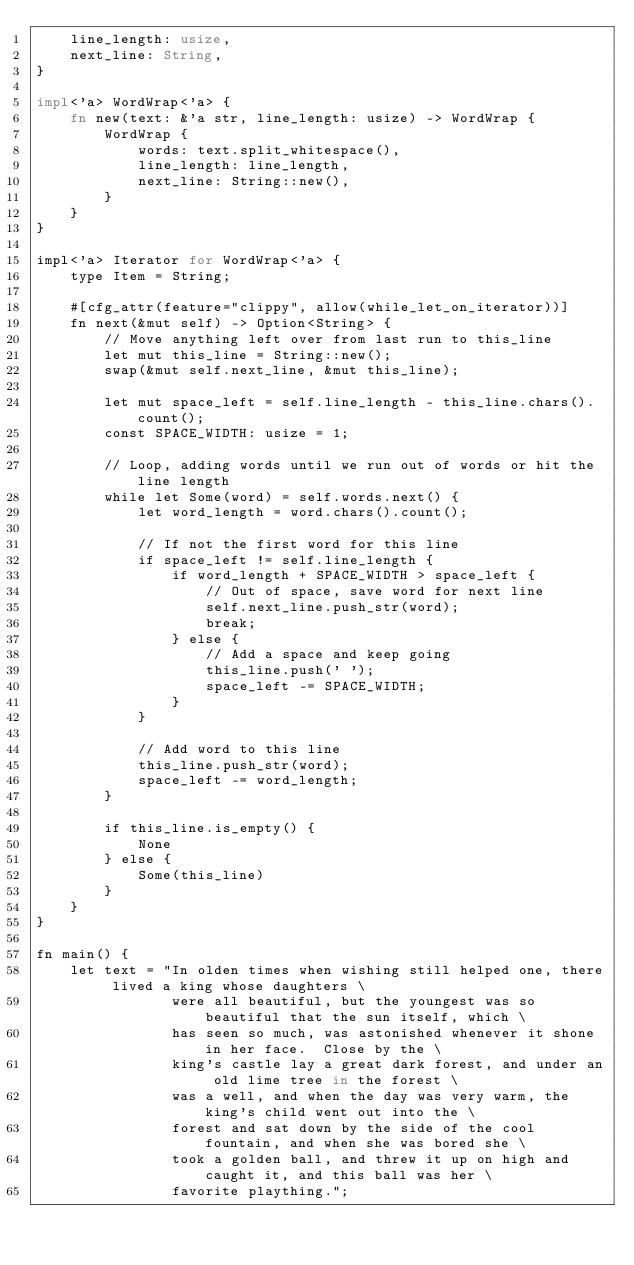<code> <loc_0><loc_0><loc_500><loc_500><_Rust_>    line_length: usize,
    next_line: String,
}

impl<'a> WordWrap<'a> {
    fn new(text: &'a str, line_length: usize) -> WordWrap {
        WordWrap {
            words: text.split_whitespace(),
            line_length: line_length,
            next_line: String::new(),
        }
    }
}

impl<'a> Iterator for WordWrap<'a> {
    type Item = String;

    #[cfg_attr(feature="clippy", allow(while_let_on_iterator))]
    fn next(&mut self) -> Option<String> {
        // Move anything left over from last run to this_line
        let mut this_line = String::new();
        swap(&mut self.next_line, &mut this_line);

        let mut space_left = self.line_length - this_line.chars().count();
        const SPACE_WIDTH: usize = 1;

        // Loop, adding words until we run out of words or hit the line length
        while let Some(word) = self.words.next() {
            let word_length = word.chars().count();

            // If not the first word for this line
            if space_left != self.line_length {
                if word_length + SPACE_WIDTH > space_left {
                    // Out of space, save word for next line
                    self.next_line.push_str(word);
                    break;
                } else {
                    // Add a space and keep going
                    this_line.push(' ');
                    space_left -= SPACE_WIDTH;
                }
            }

            // Add word to this line
            this_line.push_str(word);
            space_left -= word_length;
        }

        if this_line.is_empty() {
            None
        } else {
            Some(this_line)
        }
    }
}

fn main() {
    let text = "In olden times when wishing still helped one, there lived a king whose daughters \
                were all beautiful, but the youngest was so beautiful that the sun itself, which \
                has seen so much, was astonished whenever it shone in her face.  Close by the \
                king's castle lay a great dark forest, and under an old lime tree in the forest \
                was a well, and when the day was very warm, the king's child went out into the \
                forest and sat down by the side of the cool fountain, and when she was bored she \
                took a golden ball, and threw it up on high and caught it, and this ball was her \
                favorite plaything.";
</code> 